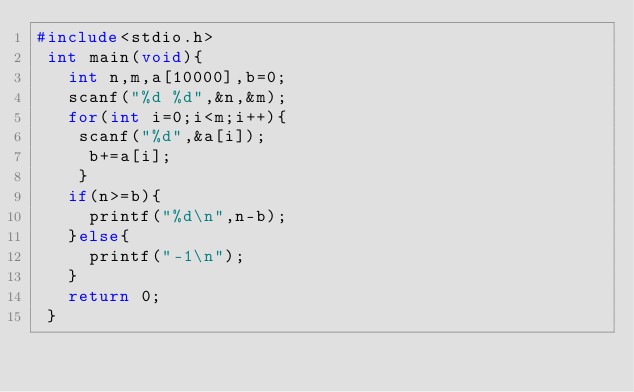<code> <loc_0><loc_0><loc_500><loc_500><_C_>#include<stdio.h>
 int main(void){
   int n,m,a[10000],b=0;
   scanf("%d %d",&n,&m);
   for(int i=0;i<m;i++){
    scanf("%d",&a[i]);  
     b+=a[i];
    }
   if(n>=b){
     printf("%d\n",n-b);
   }else{
     printf("-1\n");
   }
   return 0;
 }
      </code> 